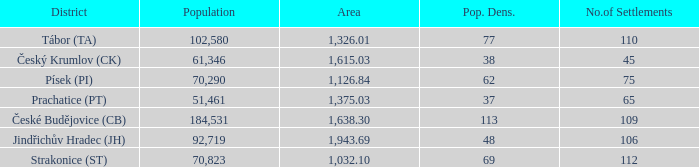How many settlements are in český krumlov (ck) with a population density higher than 38? None. 